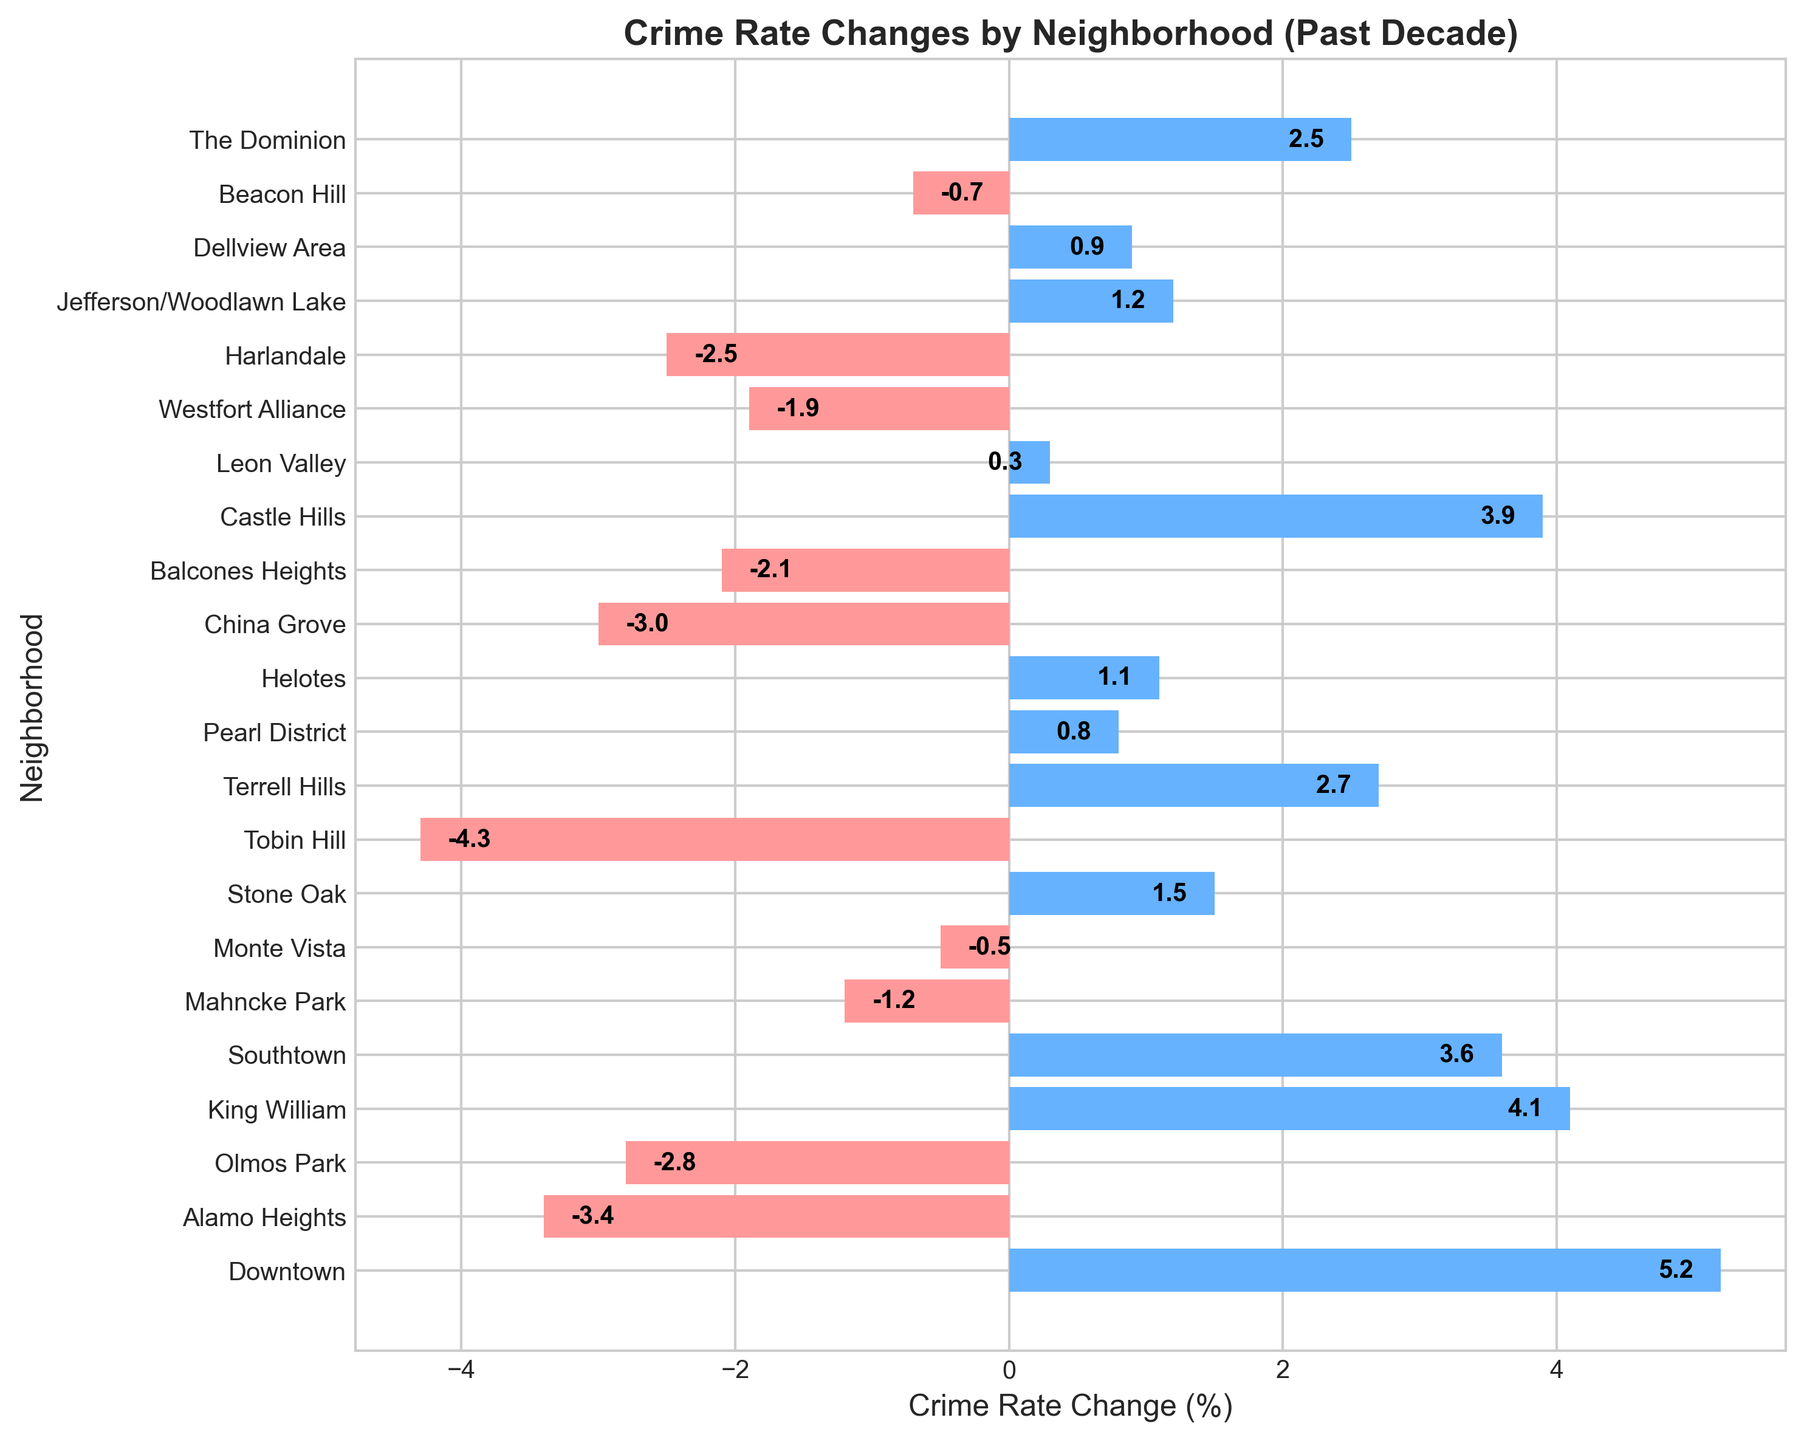Which neighborhood saw the largest decrease in crime rate? By observing the length of the bars in the negative direction (towards the left) and finding the one with the maximum magnitude, Tobin Hill has the largest decrease.
Answer: Tobin Hill Which neighborhood had a 5.2% increase in crime rate? By scanning the labels for the bars extending to the right, the first bar corresponding to "Downtown" indicates a 5.2% increase.
Answer: Downtown What is the total change in crime rate in neighborhoods where the crime rate decreased? Summing the negative changes: -3.4 + -2.8 + -1.2 + -0.5 + -4.3 + -3.0 + -2.1 + -1.9 + -2.5 + -0.7 = -22.4%
Answer: -22.4% Which neighborhoods had a crime rate decrease of at least 3%? Identifying bars on the left side with a magnitude of 3 or more: Alamo Heights, China Grove, Tobin Hill.
Answer: Alamo Heights, China Grove, Tobin Hill Which neighborhood had the smallest change in crime rate? By looking for the bar closest to zero in either direction, Leon Valley shows a 0.3% increase.
Answer: Leon Valley How many neighborhoods saw a crime rate increase? Counting the bars extending to the right of zero: Downtown, King William, Southtown, Stone Oak, Terrell Hills, Pearl District, Helotes, Castle Hills, Jefferson/Woodlawn Lake, Dellview Area, The Dominion. There are 11 in total.
Answer: 11 What is the difference in crime rate change between the neighborhood with the highest increase and the one with the highest decrease? Highest increase (Downtown): 5.2%, highest decrease (Tobin Hill): -4.3%. Difference is 5.2 - (-4.3) = 9.5%.
Answer: 9.5% Which neighborhood had a 1.5% crime rate increase? By inspecting the positive values, Stone Oak has a label indicating 1.5%.
Answer: Stone Oak Do more neighborhoods have positive or negative changes in crime rate? By counting positive and negative bars: 11 neighborhoods have positive changes, 10 neighborhoods have negative changes.
Answer: Positive 